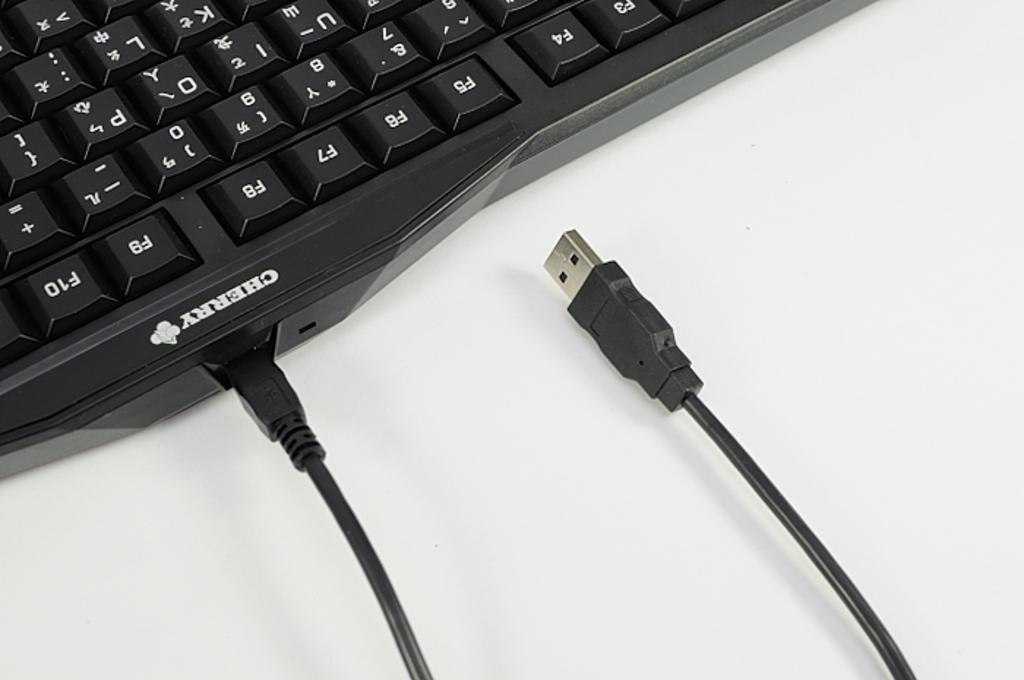<image>
Render a clear and concise summary of the photo. A keyboard that says cherry right next to the power cord. 